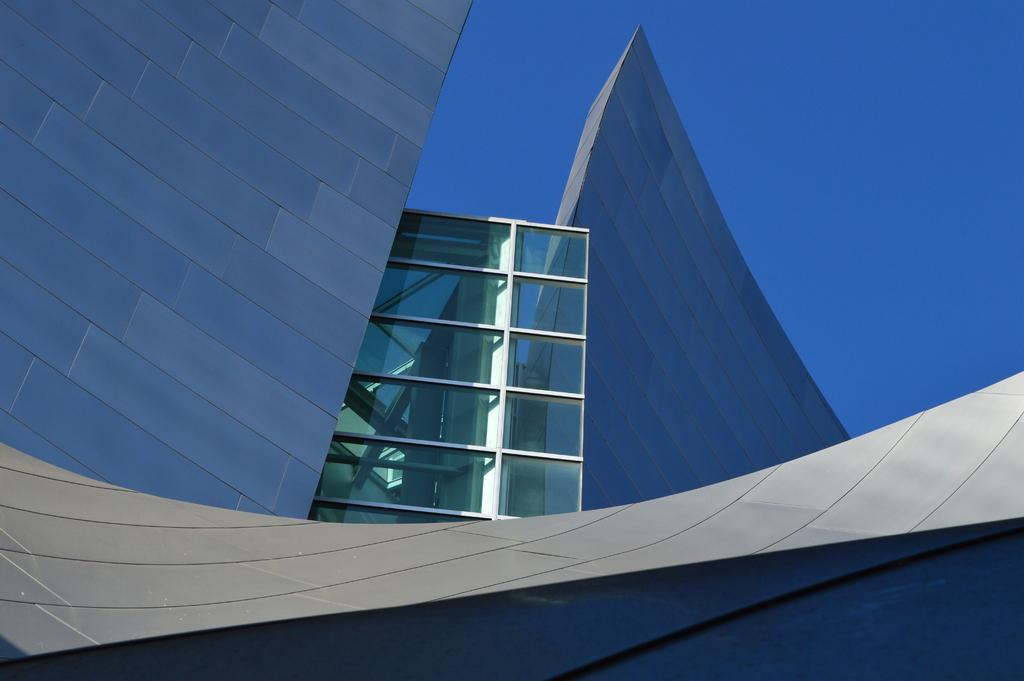What type of structures can be seen in the image? There are buildings in the image. What objects are present in the image that might be used for drinking? There are glasses in the image. What can be seen in the distance behind the buildings and glasses? The sky is visible in the background of the image. Where is the bag hanging from in the image? There is no bag present in the image. What type of appliance can be seen in the image? There is no appliance present in the image. 